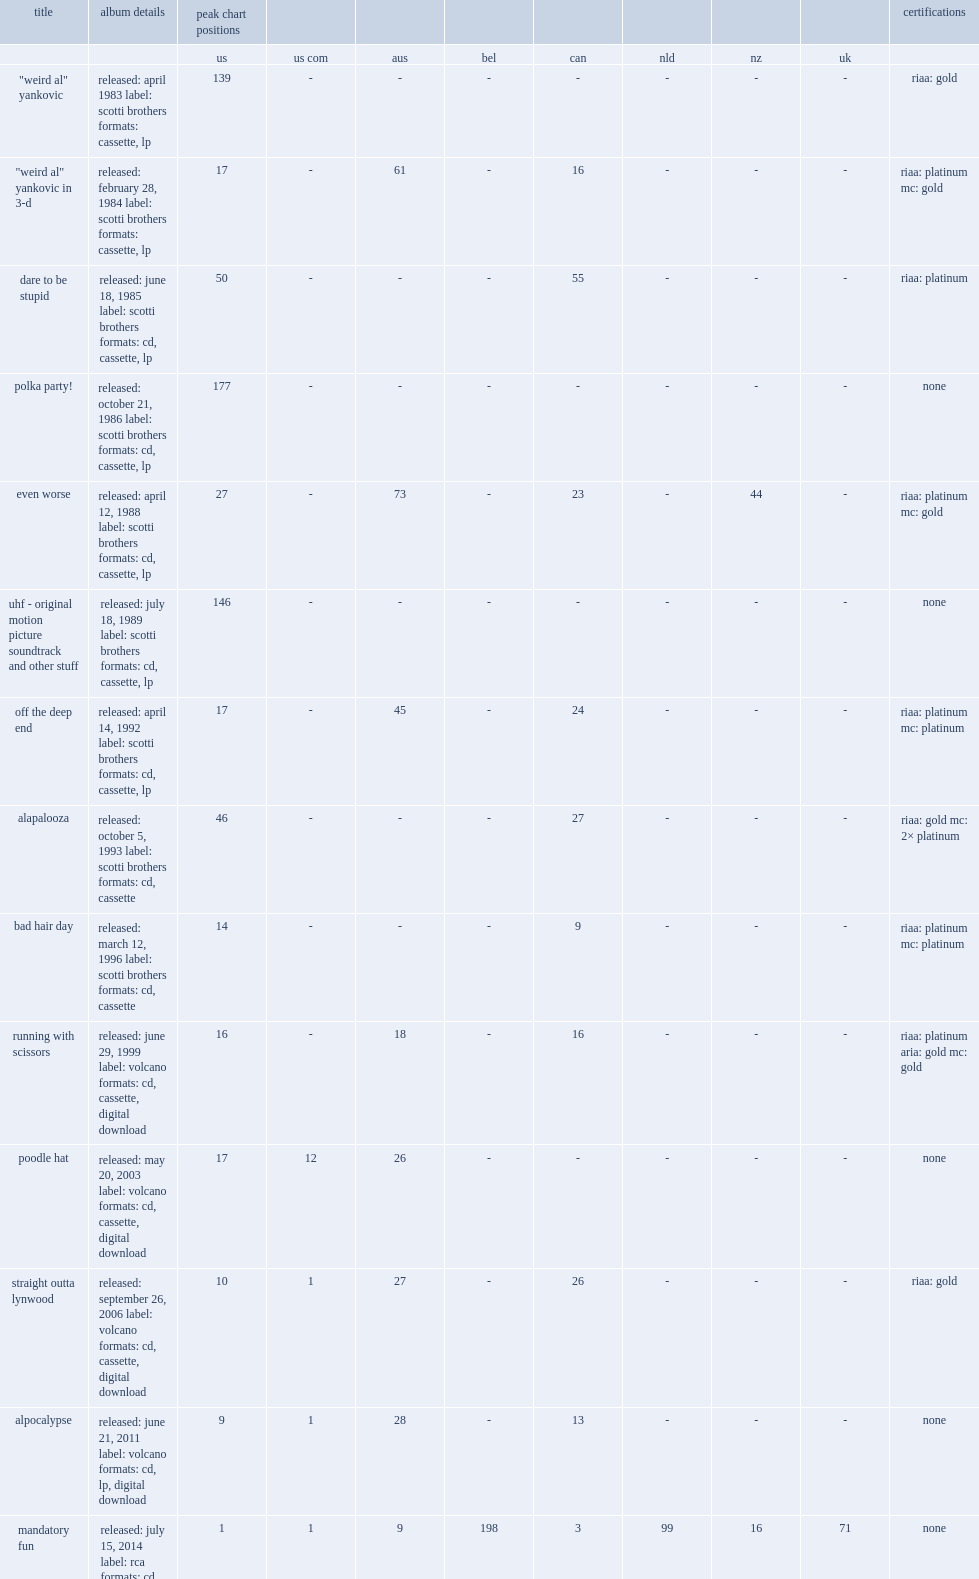What was the peak chart position on the billboard 200 of the album polka party! ? 177.0. 